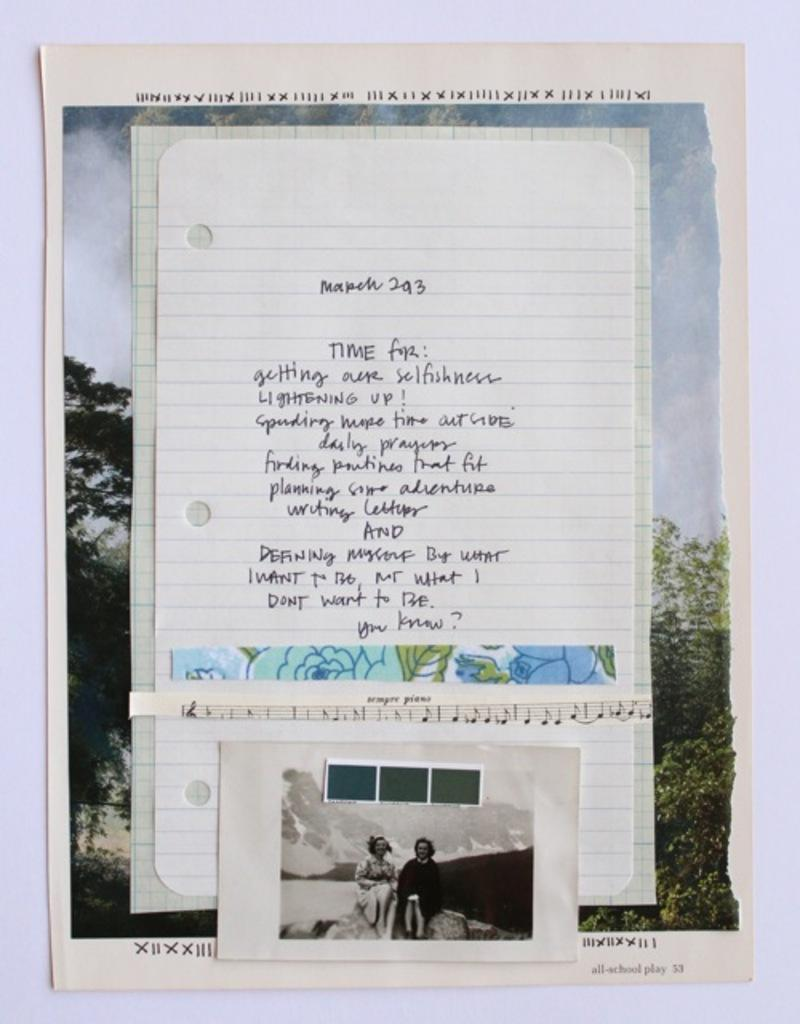<image>
Share a concise interpretation of the image provided. A hand-written paper says time for getting our selfishness . 